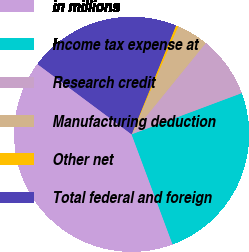<chart> <loc_0><loc_0><loc_500><loc_500><pie_chart><fcel>in millions<fcel>Income tax expense at<fcel>Research credit<fcel>Manufacturing deduction<fcel>Other net<fcel>Total federal and foreign<nl><fcel>40.88%<fcel>25.02%<fcel>8.44%<fcel>4.38%<fcel>0.32%<fcel>20.96%<nl></chart> 